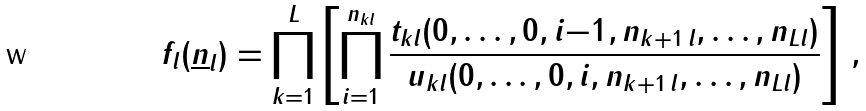<formula> <loc_0><loc_0><loc_500><loc_500>f _ { l } ( \underline { n } _ { l } ) = \prod _ { k = 1 } ^ { L } \left [ \prod _ { i = 1 } ^ { n _ { k l } } \frac { t _ { k l } ( 0 , \dots , 0 , i { - } 1 , n _ { k + 1 \, l } , \dots , n _ { L l } ) } { u _ { k l } ( 0 , \dots , 0 , i , n _ { k + 1 \, l } , \dots , n _ { L l } ) } \right ] \, ,</formula> 